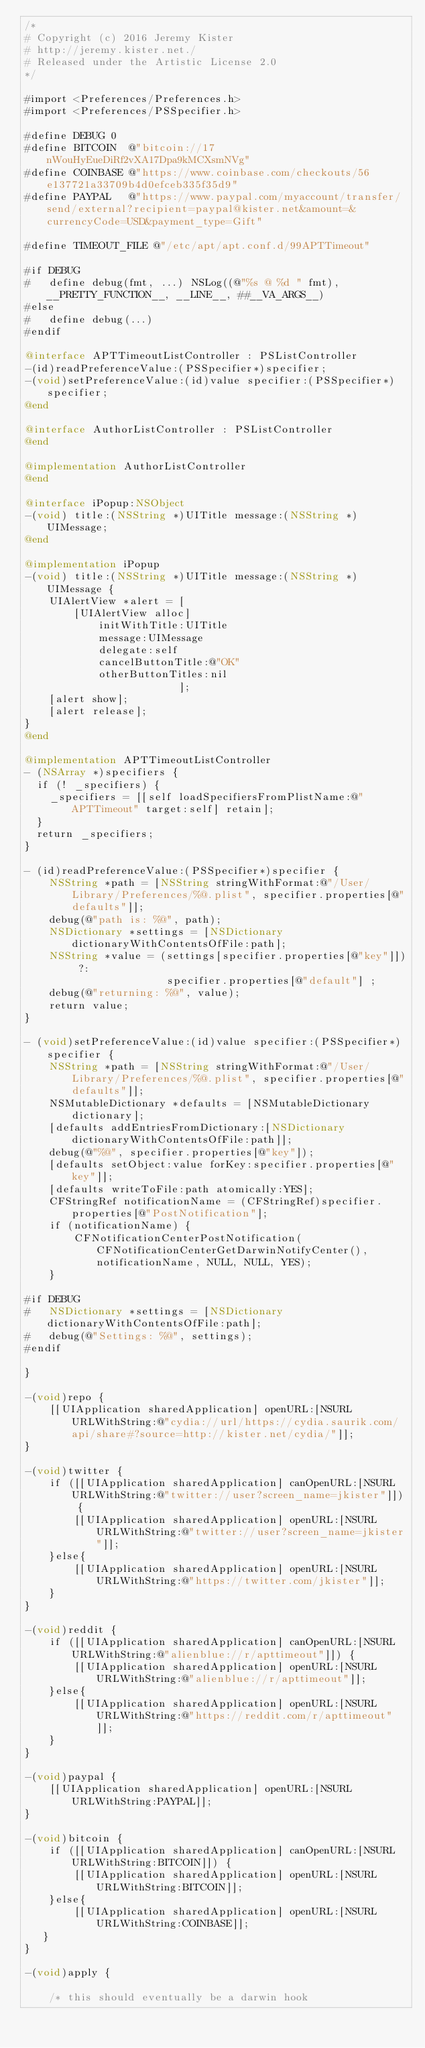Convert code to text. <code><loc_0><loc_0><loc_500><loc_500><_ObjectiveC_>/*
# Copyright (c) 2016 Jeremy Kister
# http://jeremy.kister.net./
# Released under the Artistic License 2.0
*/

#import <Preferences/Preferences.h>
#import <Preferences/PSSpecifier.h>

#define DEBUG 0
#define BITCOIN  @"bitcoin://17nWouHyEueDiRf2vXA17Dpa9kMCXsmNVg"
#define COINBASE @"https://www.coinbase.com/checkouts/56e137721a33709b4d0efceb335f35d9"
#define PAYPAL   @"https://www.paypal.com/myaccount/transfer/send/external?recipient=paypal@kister.net&amount=&currencyCode=USD&payment_type=Gift"

#define TIMEOUT_FILE @"/etc/apt/apt.conf.d/99APTTimeout"

#if DEBUG
#   define debug(fmt, ...) NSLog((@"%s @ %d " fmt), __PRETTY_FUNCTION__, __LINE__, ##__VA_ARGS__)
#else
#   define debug(...)
#endif

@interface APTTimeoutListController : PSListController
-(id)readPreferenceValue:(PSSpecifier*)specifier;
-(void)setPreferenceValue:(id)value specifier:(PSSpecifier*)specifier;
@end

@interface AuthorListController : PSListController
@end

@implementation AuthorListController
@end

@interface iPopup:NSObject
-(void) title:(NSString *)UITitle message:(NSString *)UIMessage;
@end
 
@implementation iPopup
-(void) title:(NSString *)UITitle message:(NSString *)UIMessage {
    UIAlertView *alert = [
        [UIAlertView alloc]
            initWithTitle:UITitle
            message:UIMessage
            delegate:self
            cancelButtonTitle:@"OK"
            otherButtonTitles:nil
                         ];
    [alert show];
    [alert release];
}
@end

@implementation APTTimeoutListController
- (NSArray *)specifiers {
	if (! _specifiers) {
		_specifiers = [[self loadSpecifiersFromPlistName:@"APTTimeout" target:self] retain];
	}
	return _specifiers;
}

- (id)readPreferenceValue:(PSSpecifier*)specifier {
    NSString *path = [NSString stringWithFormat:@"/User/Library/Preferences/%@.plist", specifier.properties[@"defaults"]];
    debug(@"path is: %@", path);
    NSDictionary *settings = [NSDictionary dictionaryWithContentsOfFile:path];
    NSString *value = (settings[specifier.properties[@"key"]]) ?:
                       specifier.properties[@"default"] ;
    debug(@"returning: %@", value);
    return value;
}
 
- (void)setPreferenceValue:(id)value specifier:(PSSpecifier*)specifier {
    NSString *path = [NSString stringWithFormat:@"/User/Library/Preferences/%@.plist", specifier.properties[@"defaults"]];
    NSMutableDictionary *defaults = [NSMutableDictionary dictionary];
    [defaults addEntriesFromDictionary:[NSDictionary dictionaryWithContentsOfFile:path]];
    debug(@"%@", specifier.properties[@"key"]);
    [defaults setObject:value forKey:specifier.properties[@"key"]];
    [defaults writeToFile:path atomically:YES];
    CFStringRef notificationName = (CFStringRef)specifier.properties[@"PostNotification"];
    if (notificationName) {
        CFNotificationCenterPostNotification(CFNotificationCenterGetDarwinNotifyCenter(), notificationName, NULL, NULL, YES);
    }

#if DEBUG
#   NSDictionary *settings = [NSDictionary dictionaryWithContentsOfFile:path];
#   debug(@"Settings: %@", settings);
#endif

}

-(void)repo {
    [[UIApplication sharedApplication] openURL:[NSURL URLWithString:@"cydia://url/https://cydia.saurik.com/api/share#?source=http://kister.net/cydia/"]];
}

-(void)twitter {
    if ([[UIApplication sharedApplication] canOpenURL:[NSURL URLWithString:@"twitter://user?screen_name=jkister"]]) {
        [[UIApplication sharedApplication] openURL:[NSURL URLWithString:@"twitter://user?screen_name=jkister"]];
    }else{
        [[UIApplication sharedApplication] openURL:[NSURL URLWithString:@"https://twitter.com/jkister"]];
    }
}

-(void)reddit {
    if ([[UIApplication sharedApplication] canOpenURL:[NSURL URLWithString:@"alienblue://r/apttimeout"]]) {
        [[UIApplication sharedApplication] openURL:[NSURL URLWithString:@"alienblue://r/apttimeout"]];
    }else{
        [[UIApplication sharedApplication] openURL:[NSURL URLWithString:@"https://reddit.com/r/apttimeout"]];
    }
}

-(void)paypal {
    [[UIApplication sharedApplication] openURL:[NSURL URLWithString:PAYPAL]];
}

-(void)bitcoin {
    if ([[UIApplication sharedApplication] canOpenURL:[NSURL URLWithString:BITCOIN]]) {
        [[UIApplication sharedApplication] openURL:[NSURL URLWithString:BITCOIN]];
    }else{
        [[UIApplication sharedApplication] openURL:[NSURL URLWithString:COINBASE]];
   }
}

-(void)apply {

    /* this should eventually be a darwin hook</code> 